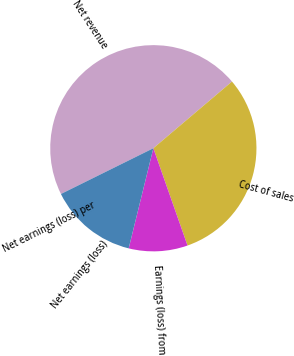Convert chart to OTSL. <chart><loc_0><loc_0><loc_500><loc_500><pie_chart><fcel>Net revenue<fcel>Cost of sales<fcel>Earnings (loss) from<fcel>Net earnings (loss)<fcel>Net earnings (loss) per<nl><fcel>46.12%<fcel>30.82%<fcel>9.22%<fcel>13.84%<fcel>0.0%<nl></chart> 